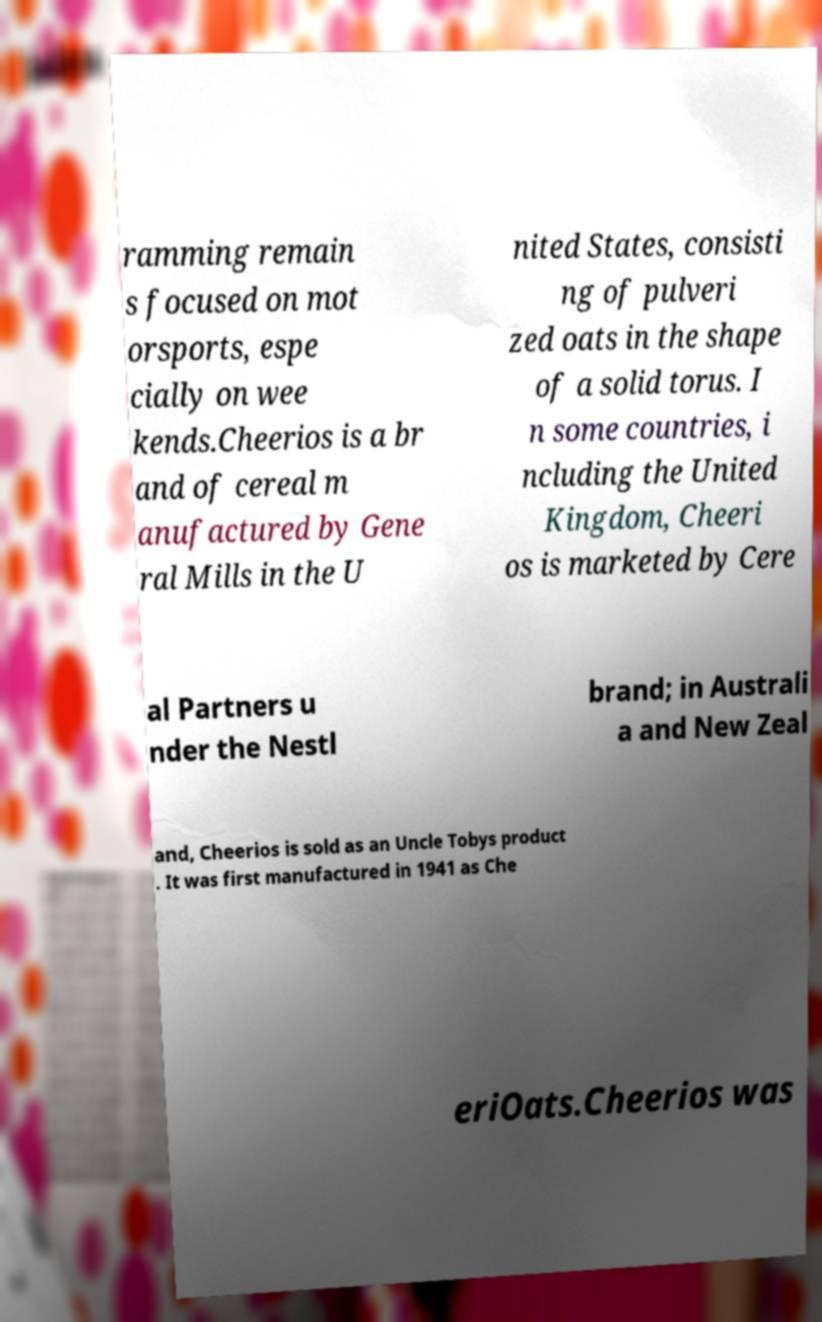I need the written content from this picture converted into text. Can you do that? ramming remain s focused on mot orsports, espe cially on wee kends.Cheerios is a br and of cereal m anufactured by Gene ral Mills in the U nited States, consisti ng of pulveri zed oats in the shape of a solid torus. I n some countries, i ncluding the United Kingdom, Cheeri os is marketed by Cere al Partners u nder the Nestl brand; in Australi a and New Zeal and, Cheerios is sold as an Uncle Tobys product . It was first manufactured in 1941 as Che eriOats.Cheerios was 